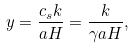Convert formula to latex. <formula><loc_0><loc_0><loc_500><loc_500>y = \frac { c _ { s } k } { a H } = \frac { k } { \gamma a H } ,</formula> 